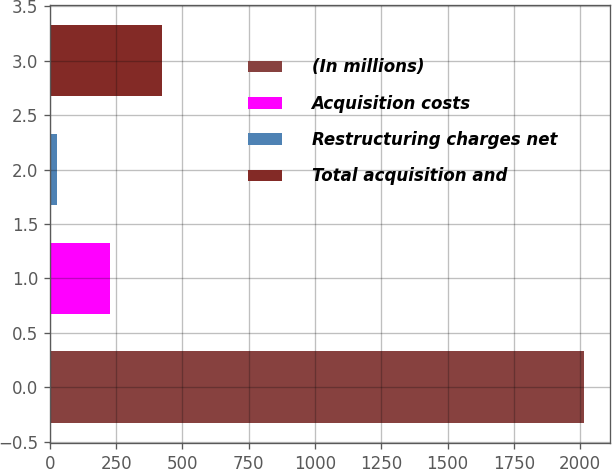<chart> <loc_0><loc_0><loc_500><loc_500><bar_chart><fcel>(In millions)<fcel>Acquisition costs<fcel>Restructuring charges net<fcel>Total acquisition and<nl><fcel>2013<fcel>226.5<fcel>28<fcel>425<nl></chart> 